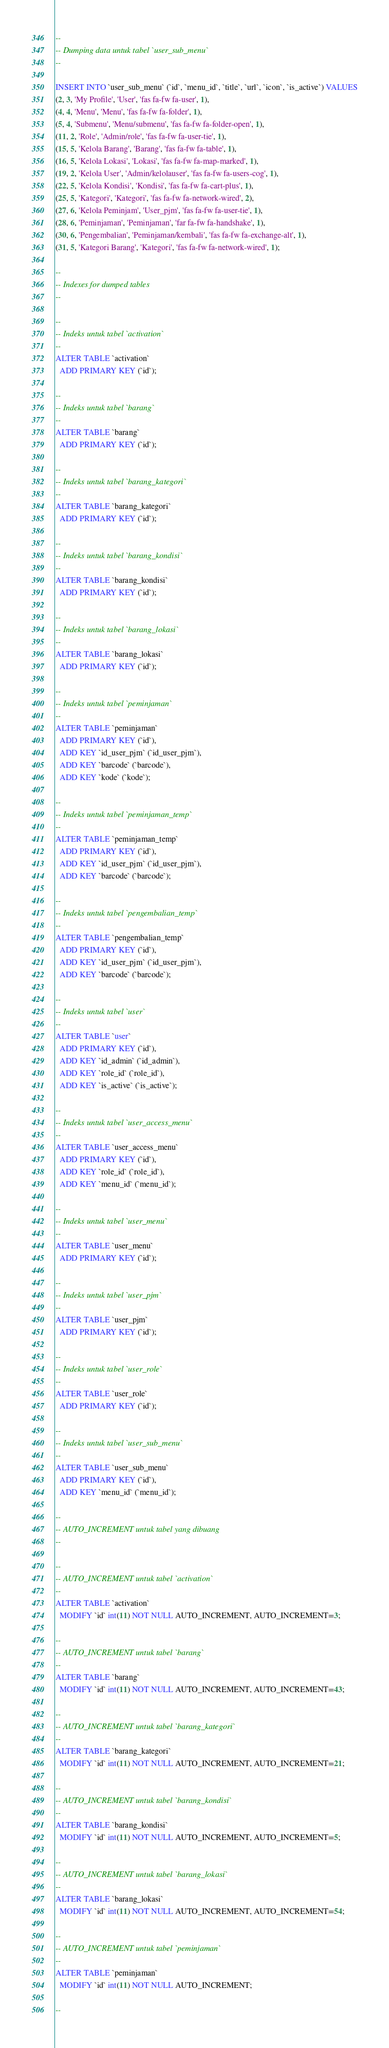Convert code to text. <code><loc_0><loc_0><loc_500><loc_500><_SQL_>--
-- Dumping data untuk tabel `user_sub_menu`
--

INSERT INTO `user_sub_menu` (`id`, `menu_id`, `title`, `url`, `icon`, `is_active`) VALUES
(2, 3, 'My Profile', 'User', 'fas fa-fw fa-user', 1),
(4, 4, 'Menu', 'Menu', 'fas fa-fw fa-folder', 1),
(5, 4, 'Submenu', 'Menu/submenu', 'fas fa-fw fa-folder-open', 1),
(11, 2, 'Role', 'Admin/role', 'fas fa-fw fa-user-tie', 1),
(15, 5, 'Kelola Barang', 'Barang', 'fas fa-fw fa-table', 1),
(16, 5, 'Kelola Lokasi', 'Lokasi', 'fas fa-fw fa-map-marked', 1),
(19, 2, 'Kelola User', 'Admin/kelolauser', 'fas fa-fw fa-users-cog', 1),
(22, 5, 'Kelola Kondisi', 'Kondisi', 'fas fa-fw fa-cart-plus', 1),
(25, 5, 'Kategori', 'Kategori', 'fas fa-fw fa-network-wired', 2),
(27, 6, 'Kelola Peminjam', 'User_pjm', 'fas fa-fw fa-user-tie', 1),
(28, 6, 'Peminjaman', 'Peminjaman', 'far fa-fw fa-handshake', 1),
(30, 6, 'Pengembalian', 'Peminjaman/kembali', 'fas fa-fw fa-exchange-alt', 1),
(31, 5, 'Kategori Barang', 'Kategori', 'fas fa-fw fa-network-wired', 1);

--
-- Indexes for dumped tables
--

--
-- Indeks untuk tabel `activation`
--
ALTER TABLE `activation`
  ADD PRIMARY KEY (`id`);

--
-- Indeks untuk tabel `barang`
--
ALTER TABLE `barang`
  ADD PRIMARY KEY (`id`);

--
-- Indeks untuk tabel `barang_kategori`
--
ALTER TABLE `barang_kategori`
  ADD PRIMARY KEY (`id`);

--
-- Indeks untuk tabel `barang_kondisi`
--
ALTER TABLE `barang_kondisi`
  ADD PRIMARY KEY (`id`);

--
-- Indeks untuk tabel `barang_lokasi`
--
ALTER TABLE `barang_lokasi`
  ADD PRIMARY KEY (`id`);

--
-- Indeks untuk tabel `peminjaman`
--
ALTER TABLE `peminjaman`
  ADD PRIMARY KEY (`id`),
  ADD KEY `id_user_pjm` (`id_user_pjm`),
  ADD KEY `barcode` (`barcode`),
  ADD KEY `kode` (`kode`);

--
-- Indeks untuk tabel `peminjaman_temp`
--
ALTER TABLE `peminjaman_temp`
  ADD PRIMARY KEY (`id`),
  ADD KEY `id_user_pjm` (`id_user_pjm`),
  ADD KEY `barcode` (`barcode`);

--
-- Indeks untuk tabel `pengembalian_temp`
--
ALTER TABLE `pengembalian_temp`
  ADD PRIMARY KEY (`id`),
  ADD KEY `id_user_pjm` (`id_user_pjm`),
  ADD KEY `barcode` (`barcode`);

--
-- Indeks untuk tabel `user`
--
ALTER TABLE `user`
  ADD PRIMARY KEY (`id`),
  ADD KEY `id_admin` (`id_admin`),
  ADD KEY `role_id` (`role_id`),
  ADD KEY `is_active` (`is_active`);

--
-- Indeks untuk tabel `user_access_menu`
--
ALTER TABLE `user_access_menu`
  ADD PRIMARY KEY (`id`),
  ADD KEY `role_id` (`role_id`),
  ADD KEY `menu_id` (`menu_id`);

--
-- Indeks untuk tabel `user_menu`
--
ALTER TABLE `user_menu`
  ADD PRIMARY KEY (`id`);

--
-- Indeks untuk tabel `user_pjm`
--
ALTER TABLE `user_pjm`
  ADD PRIMARY KEY (`id`);

--
-- Indeks untuk tabel `user_role`
--
ALTER TABLE `user_role`
  ADD PRIMARY KEY (`id`);

--
-- Indeks untuk tabel `user_sub_menu`
--
ALTER TABLE `user_sub_menu`
  ADD PRIMARY KEY (`id`),
  ADD KEY `menu_id` (`menu_id`);

--
-- AUTO_INCREMENT untuk tabel yang dibuang
--

--
-- AUTO_INCREMENT untuk tabel `activation`
--
ALTER TABLE `activation`
  MODIFY `id` int(11) NOT NULL AUTO_INCREMENT, AUTO_INCREMENT=3;

--
-- AUTO_INCREMENT untuk tabel `barang`
--
ALTER TABLE `barang`
  MODIFY `id` int(11) NOT NULL AUTO_INCREMENT, AUTO_INCREMENT=43;

--
-- AUTO_INCREMENT untuk tabel `barang_kategori`
--
ALTER TABLE `barang_kategori`
  MODIFY `id` int(11) NOT NULL AUTO_INCREMENT, AUTO_INCREMENT=21;

--
-- AUTO_INCREMENT untuk tabel `barang_kondisi`
--
ALTER TABLE `barang_kondisi`
  MODIFY `id` int(11) NOT NULL AUTO_INCREMENT, AUTO_INCREMENT=5;

--
-- AUTO_INCREMENT untuk tabel `barang_lokasi`
--
ALTER TABLE `barang_lokasi`
  MODIFY `id` int(11) NOT NULL AUTO_INCREMENT, AUTO_INCREMENT=54;

--
-- AUTO_INCREMENT untuk tabel `peminjaman`
--
ALTER TABLE `peminjaman`
  MODIFY `id` int(11) NOT NULL AUTO_INCREMENT;

--</code> 